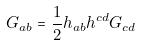<formula> <loc_0><loc_0><loc_500><loc_500>G _ { a b } = \frac { 1 } { 2 } h _ { a b } h ^ { c d } G _ { c d }</formula> 